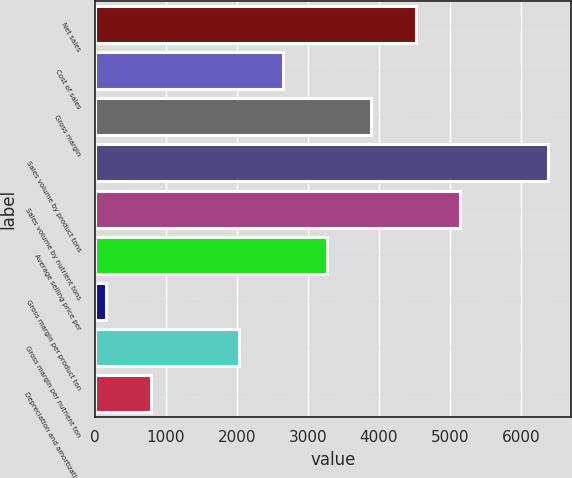<chart> <loc_0><loc_0><loc_500><loc_500><bar_chart><fcel>Net sales<fcel>Cost of sales<fcel>Gross margin<fcel>Sales volume by product tons<fcel>Sales volume by nutrient tons<fcel>Average selling price per<fcel>Gross margin per product ton<fcel>Gross margin per nutrient ton<fcel>Depreciation and amortization<nl><fcel>4517<fcel>2651<fcel>3895<fcel>6383<fcel>5139<fcel>3273<fcel>163<fcel>2029<fcel>785<nl></chart> 